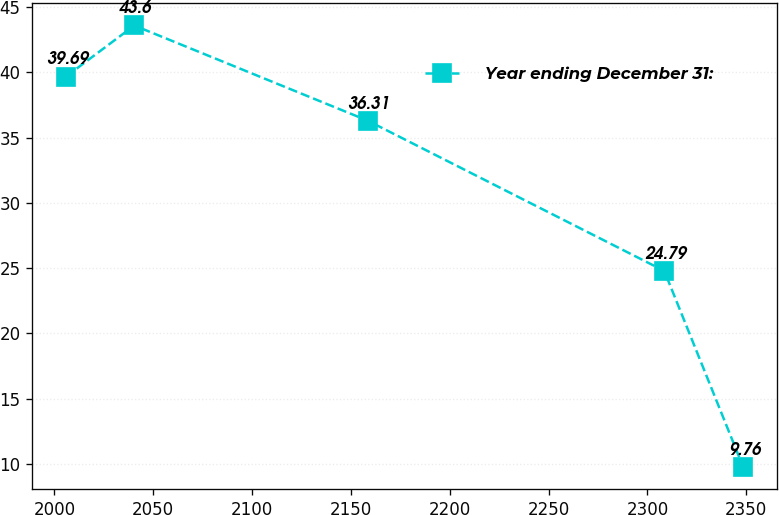Convert chart. <chart><loc_0><loc_0><loc_500><loc_500><line_chart><ecel><fcel>Year ending December 31:<nl><fcel>2005.93<fcel>39.69<nl><fcel>2040.41<fcel>43.6<nl><fcel>2158.45<fcel>36.31<nl><fcel>2308.51<fcel>24.79<nl><fcel>2348.4<fcel>9.76<nl></chart> 